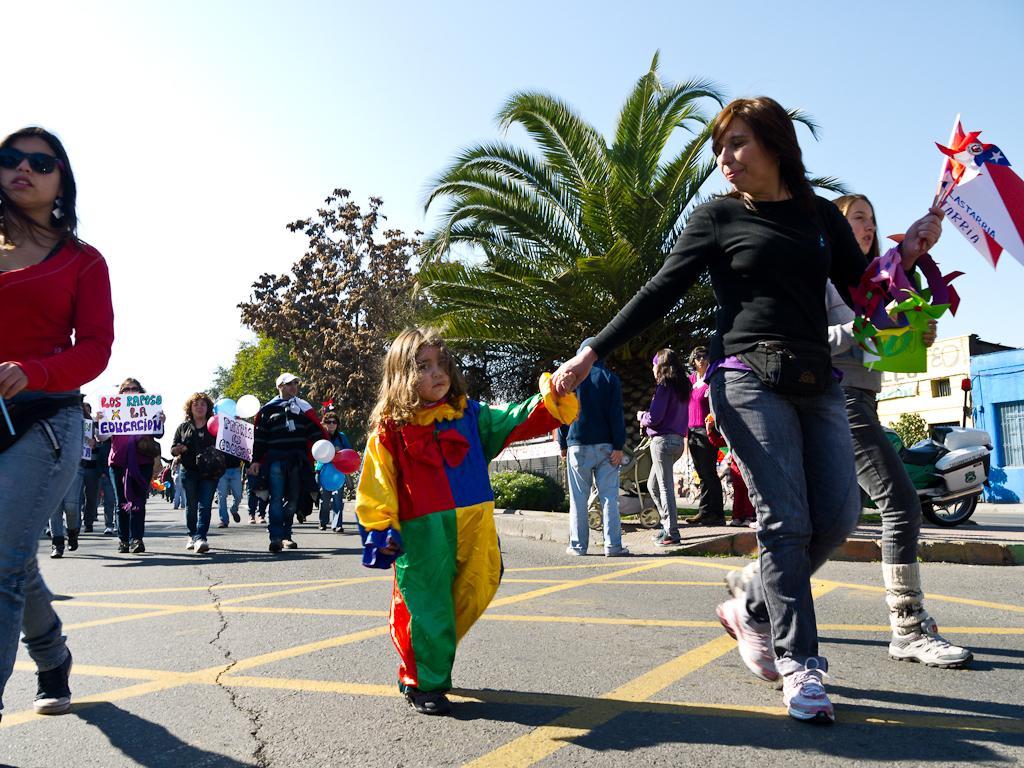Describe this image in one or two sentences. As we can see in the image there are few people walking here and there, flags, banners, trees, buildings, motor cycle and sky. 